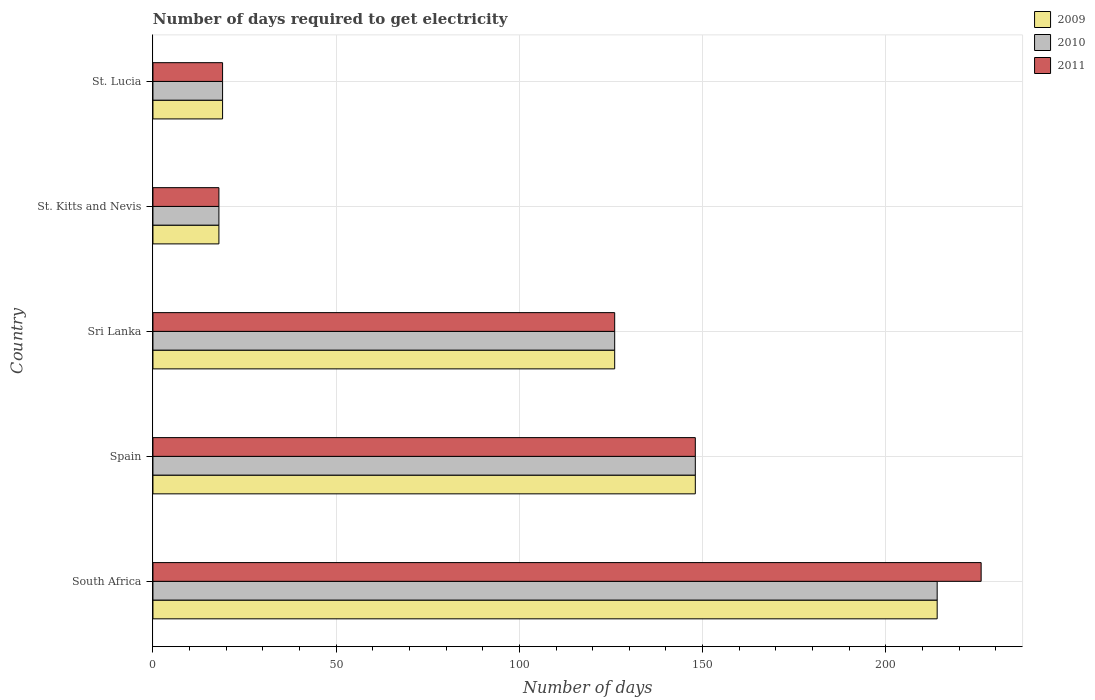How many groups of bars are there?
Provide a succinct answer. 5. Are the number of bars per tick equal to the number of legend labels?
Your response must be concise. Yes. How many bars are there on the 2nd tick from the top?
Your answer should be compact. 3. How many bars are there on the 5th tick from the bottom?
Your answer should be very brief. 3. What is the label of the 3rd group of bars from the top?
Your response must be concise. Sri Lanka. Across all countries, what is the maximum number of days required to get electricity in in 2010?
Your response must be concise. 214. Across all countries, what is the minimum number of days required to get electricity in in 2011?
Your response must be concise. 18. In which country was the number of days required to get electricity in in 2011 maximum?
Keep it short and to the point. South Africa. In which country was the number of days required to get electricity in in 2009 minimum?
Offer a very short reply. St. Kitts and Nevis. What is the total number of days required to get electricity in in 2011 in the graph?
Your answer should be compact. 537. What is the difference between the number of days required to get electricity in in 2010 in Spain and that in Sri Lanka?
Ensure brevity in your answer.  22. What is the difference between the number of days required to get electricity in in 2011 in South Africa and the number of days required to get electricity in in 2010 in St. Lucia?
Provide a short and direct response. 207. What is the average number of days required to get electricity in in 2009 per country?
Keep it short and to the point. 105. What is the difference between the number of days required to get electricity in in 2011 and number of days required to get electricity in in 2010 in Sri Lanka?
Your answer should be compact. 0. In how many countries, is the number of days required to get electricity in in 2011 greater than 200 days?
Offer a terse response. 1. What is the ratio of the number of days required to get electricity in in 2010 in Spain to that in St. Lucia?
Provide a succinct answer. 7.79. Is the difference between the number of days required to get electricity in in 2011 in South Africa and St. Kitts and Nevis greater than the difference between the number of days required to get electricity in in 2010 in South Africa and St. Kitts and Nevis?
Offer a very short reply. Yes. What is the difference between the highest and the second highest number of days required to get electricity in in 2010?
Offer a terse response. 66. What is the difference between the highest and the lowest number of days required to get electricity in in 2009?
Ensure brevity in your answer.  196. Is the sum of the number of days required to get electricity in in 2011 in St. Kitts and Nevis and St. Lucia greater than the maximum number of days required to get electricity in in 2009 across all countries?
Offer a very short reply. No. What does the 1st bar from the bottom in Sri Lanka represents?
Provide a short and direct response. 2009. Is it the case that in every country, the sum of the number of days required to get electricity in in 2011 and number of days required to get electricity in in 2009 is greater than the number of days required to get electricity in in 2010?
Offer a very short reply. Yes. How many bars are there?
Your answer should be very brief. 15. How many countries are there in the graph?
Give a very brief answer. 5. What is the difference between two consecutive major ticks on the X-axis?
Keep it short and to the point. 50. Does the graph contain any zero values?
Provide a short and direct response. No. Does the graph contain grids?
Your answer should be very brief. Yes. Where does the legend appear in the graph?
Keep it short and to the point. Top right. How many legend labels are there?
Provide a succinct answer. 3. What is the title of the graph?
Keep it short and to the point. Number of days required to get electricity. Does "1968" appear as one of the legend labels in the graph?
Offer a very short reply. No. What is the label or title of the X-axis?
Give a very brief answer. Number of days. What is the Number of days in 2009 in South Africa?
Provide a succinct answer. 214. What is the Number of days of 2010 in South Africa?
Give a very brief answer. 214. What is the Number of days of 2011 in South Africa?
Provide a succinct answer. 226. What is the Number of days in 2009 in Spain?
Your response must be concise. 148. What is the Number of days of 2010 in Spain?
Offer a terse response. 148. What is the Number of days of 2011 in Spain?
Give a very brief answer. 148. What is the Number of days of 2009 in Sri Lanka?
Offer a very short reply. 126. What is the Number of days of 2010 in Sri Lanka?
Provide a short and direct response. 126. What is the Number of days in 2011 in Sri Lanka?
Provide a short and direct response. 126. What is the Number of days of 2009 in St. Kitts and Nevis?
Your response must be concise. 18. What is the Number of days in 2010 in St. Lucia?
Offer a terse response. 19. What is the Number of days in 2011 in St. Lucia?
Give a very brief answer. 19. Across all countries, what is the maximum Number of days of 2009?
Give a very brief answer. 214. Across all countries, what is the maximum Number of days of 2010?
Provide a short and direct response. 214. Across all countries, what is the maximum Number of days of 2011?
Your answer should be very brief. 226. Across all countries, what is the minimum Number of days of 2010?
Make the answer very short. 18. What is the total Number of days of 2009 in the graph?
Your answer should be very brief. 525. What is the total Number of days in 2010 in the graph?
Provide a short and direct response. 525. What is the total Number of days in 2011 in the graph?
Your response must be concise. 537. What is the difference between the Number of days in 2009 in South Africa and that in Spain?
Your response must be concise. 66. What is the difference between the Number of days of 2010 in South Africa and that in Spain?
Ensure brevity in your answer.  66. What is the difference between the Number of days of 2011 in South Africa and that in Spain?
Make the answer very short. 78. What is the difference between the Number of days in 2009 in South Africa and that in Sri Lanka?
Provide a succinct answer. 88. What is the difference between the Number of days of 2010 in South Africa and that in Sri Lanka?
Provide a short and direct response. 88. What is the difference between the Number of days in 2009 in South Africa and that in St. Kitts and Nevis?
Give a very brief answer. 196. What is the difference between the Number of days in 2010 in South Africa and that in St. Kitts and Nevis?
Your answer should be very brief. 196. What is the difference between the Number of days of 2011 in South Africa and that in St. Kitts and Nevis?
Your answer should be very brief. 208. What is the difference between the Number of days of 2009 in South Africa and that in St. Lucia?
Provide a short and direct response. 195. What is the difference between the Number of days of 2010 in South Africa and that in St. Lucia?
Your response must be concise. 195. What is the difference between the Number of days in 2011 in South Africa and that in St. Lucia?
Give a very brief answer. 207. What is the difference between the Number of days in 2009 in Spain and that in Sri Lanka?
Offer a very short reply. 22. What is the difference between the Number of days in 2011 in Spain and that in Sri Lanka?
Keep it short and to the point. 22. What is the difference between the Number of days in 2009 in Spain and that in St. Kitts and Nevis?
Give a very brief answer. 130. What is the difference between the Number of days of 2010 in Spain and that in St. Kitts and Nevis?
Your response must be concise. 130. What is the difference between the Number of days in 2011 in Spain and that in St. Kitts and Nevis?
Ensure brevity in your answer.  130. What is the difference between the Number of days in 2009 in Spain and that in St. Lucia?
Give a very brief answer. 129. What is the difference between the Number of days of 2010 in Spain and that in St. Lucia?
Your answer should be very brief. 129. What is the difference between the Number of days in 2011 in Spain and that in St. Lucia?
Keep it short and to the point. 129. What is the difference between the Number of days in 2009 in Sri Lanka and that in St. Kitts and Nevis?
Your response must be concise. 108. What is the difference between the Number of days of 2010 in Sri Lanka and that in St. Kitts and Nevis?
Give a very brief answer. 108. What is the difference between the Number of days in 2011 in Sri Lanka and that in St. Kitts and Nevis?
Offer a very short reply. 108. What is the difference between the Number of days of 2009 in Sri Lanka and that in St. Lucia?
Make the answer very short. 107. What is the difference between the Number of days of 2010 in Sri Lanka and that in St. Lucia?
Your response must be concise. 107. What is the difference between the Number of days of 2011 in Sri Lanka and that in St. Lucia?
Make the answer very short. 107. What is the difference between the Number of days in 2009 in St. Kitts and Nevis and that in St. Lucia?
Provide a succinct answer. -1. What is the difference between the Number of days in 2010 in St. Kitts and Nevis and that in St. Lucia?
Offer a very short reply. -1. What is the difference between the Number of days of 2011 in St. Kitts and Nevis and that in St. Lucia?
Your answer should be compact. -1. What is the difference between the Number of days of 2009 in South Africa and the Number of days of 2011 in Spain?
Your answer should be compact. 66. What is the difference between the Number of days in 2010 in South Africa and the Number of days in 2011 in Spain?
Your answer should be very brief. 66. What is the difference between the Number of days of 2009 in South Africa and the Number of days of 2010 in Sri Lanka?
Provide a succinct answer. 88. What is the difference between the Number of days in 2009 in South Africa and the Number of days in 2011 in Sri Lanka?
Provide a succinct answer. 88. What is the difference between the Number of days in 2009 in South Africa and the Number of days in 2010 in St. Kitts and Nevis?
Offer a very short reply. 196. What is the difference between the Number of days in 2009 in South Africa and the Number of days in 2011 in St. Kitts and Nevis?
Keep it short and to the point. 196. What is the difference between the Number of days in 2010 in South Africa and the Number of days in 2011 in St. Kitts and Nevis?
Provide a succinct answer. 196. What is the difference between the Number of days of 2009 in South Africa and the Number of days of 2010 in St. Lucia?
Ensure brevity in your answer.  195. What is the difference between the Number of days of 2009 in South Africa and the Number of days of 2011 in St. Lucia?
Offer a very short reply. 195. What is the difference between the Number of days in 2010 in South Africa and the Number of days in 2011 in St. Lucia?
Make the answer very short. 195. What is the difference between the Number of days in 2009 in Spain and the Number of days in 2011 in Sri Lanka?
Provide a succinct answer. 22. What is the difference between the Number of days in 2009 in Spain and the Number of days in 2010 in St. Kitts and Nevis?
Offer a terse response. 130. What is the difference between the Number of days in 2009 in Spain and the Number of days in 2011 in St. Kitts and Nevis?
Provide a short and direct response. 130. What is the difference between the Number of days of 2010 in Spain and the Number of days of 2011 in St. Kitts and Nevis?
Ensure brevity in your answer.  130. What is the difference between the Number of days of 2009 in Spain and the Number of days of 2010 in St. Lucia?
Offer a very short reply. 129. What is the difference between the Number of days of 2009 in Spain and the Number of days of 2011 in St. Lucia?
Provide a succinct answer. 129. What is the difference between the Number of days in 2010 in Spain and the Number of days in 2011 in St. Lucia?
Ensure brevity in your answer.  129. What is the difference between the Number of days of 2009 in Sri Lanka and the Number of days of 2010 in St. Kitts and Nevis?
Offer a very short reply. 108. What is the difference between the Number of days of 2009 in Sri Lanka and the Number of days of 2011 in St. Kitts and Nevis?
Your answer should be compact. 108. What is the difference between the Number of days of 2010 in Sri Lanka and the Number of days of 2011 in St. Kitts and Nevis?
Make the answer very short. 108. What is the difference between the Number of days in 2009 in Sri Lanka and the Number of days in 2010 in St. Lucia?
Your response must be concise. 107. What is the difference between the Number of days in 2009 in Sri Lanka and the Number of days in 2011 in St. Lucia?
Ensure brevity in your answer.  107. What is the difference between the Number of days in 2010 in Sri Lanka and the Number of days in 2011 in St. Lucia?
Provide a short and direct response. 107. What is the difference between the Number of days of 2009 in St. Kitts and Nevis and the Number of days of 2010 in St. Lucia?
Keep it short and to the point. -1. What is the difference between the Number of days of 2010 in St. Kitts and Nevis and the Number of days of 2011 in St. Lucia?
Make the answer very short. -1. What is the average Number of days in 2009 per country?
Offer a very short reply. 105. What is the average Number of days of 2010 per country?
Provide a succinct answer. 105. What is the average Number of days in 2011 per country?
Your response must be concise. 107.4. What is the difference between the Number of days of 2009 and Number of days of 2010 in South Africa?
Provide a short and direct response. 0. What is the difference between the Number of days in 2009 and Number of days in 2011 in South Africa?
Your answer should be very brief. -12. What is the difference between the Number of days in 2009 and Number of days in 2010 in Spain?
Give a very brief answer. 0. What is the difference between the Number of days in 2009 and Number of days in 2011 in Spain?
Offer a terse response. 0. What is the difference between the Number of days in 2010 and Number of days in 2011 in Spain?
Provide a succinct answer. 0. What is the difference between the Number of days of 2010 and Number of days of 2011 in Sri Lanka?
Offer a very short reply. 0. What is the difference between the Number of days in 2009 and Number of days in 2011 in St. Kitts and Nevis?
Make the answer very short. 0. What is the difference between the Number of days in 2010 and Number of days in 2011 in St. Kitts and Nevis?
Provide a succinct answer. 0. What is the difference between the Number of days of 2009 and Number of days of 2010 in St. Lucia?
Offer a terse response. 0. What is the difference between the Number of days of 2009 and Number of days of 2011 in St. Lucia?
Your answer should be compact. 0. What is the ratio of the Number of days in 2009 in South Africa to that in Spain?
Make the answer very short. 1.45. What is the ratio of the Number of days in 2010 in South Africa to that in Spain?
Offer a terse response. 1.45. What is the ratio of the Number of days of 2011 in South Africa to that in Spain?
Keep it short and to the point. 1.53. What is the ratio of the Number of days of 2009 in South Africa to that in Sri Lanka?
Provide a short and direct response. 1.7. What is the ratio of the Number of days of 2010 in South Africa to that in Sri Lanka?
Provide a succinct answer. 1.7. What is the ratio of the Number of days of 2011 in South Africa to that in Sri Lanka?
Provide a short and direct response. 1.79. What is the ratio of the Number of days in 2009 in South Africa to that in St. Kitts and Nevis?
Give a very brief answer. 11.89. What is the ratio of the Number of days in 2010 in South Africa to that in St. Kitts and Nevis?
Provide a succinct answer. 11.89. What is the ratio of the Number of days in 2011 in South Africa to that in St. Kitts and Nevis?
Make the answer very short. 12.56. What is the ratio of the Number of days of 2009 in South Africa to that in St. Lucia?
Keep it short and to the point. 11.26. What is the ratio of the Number of days in 2010 in South Africa to that in St. Lucia?
Your response must be concise. 11.26. What is the ratio of the Number of days of 2011 in South Africa to that in St. Lucia?
Your response must be concise. 11.89. What is the ratio of the Number of days of 2009 in Spain to that in Sri Lanka?
Offer a very short reply. 1.17. What is the ratio of the Number of days in 2010 in Spain to that in Sri Lanka?
Make the answer very short. 1.17. What is the ratio of the Number of days of 2011 in Spain to that in Sri Lanka?
Keep it short and to the point. 1.17. What is the ratio of the Number of days of 2009 in Spain to that in St. Kitts and Nevis?
Offer a terse response. 8.22. What is the ratio of the Number of days in 2010 in Spain to that in St. Kitts and Nevis?
Provide a short and direct response. 8.22. What is the ratio of the Number of days of 2011 in Spain to that in St. Kitts and Nevis?
Ensure brevity in your answer.  8.22. What is the ratio of the Number of days of 2009 in Spain to that in St. Lucia?
Keep it short and to the point. 7.79. What is the ratio of the Number of days of 2010 in Spain to that in St. Lucia?
Provide a succinct answer. 7.79. What is the ratio of the Number of days in 2011 in Spain to that in St. Lucia?
Offer a terse response. 7.79. What is the ratio of the Number of days in 2009 in Sri Lanka to that in St. Kitts and Nevis?
Your answer should be very brief. 7. What is the ratio of the Number of days in 2009 in Sri Lanka to that in St. Lucia?
Ensure brevity in your answer.  6.63. What is the ratio of the Number of days in 2010 in Sri Lanka to that in St. Lucia?
Provide a short and direct response. 6.63. What is the ratio of the Number of days in 2011 in Sri Lanka to that in St. Lucia?
Give a very brief answer. 6.63. What is the ratio of the Number of days in 2009 in St. Kitts and Nevis to that in St. Lucia?
Your response must be concise. 0.95. What is the ratio of the Number of days in 2011 in St. Kitts and Nevis to that in St. Lucia?
Offer a terse response. 0.95. What is the difference between the highest and the second highest Number of days of 2009?
Your answer should be compact. 66. What is the difference between the highest and the second highest Number of days in 2010?
Ensure brevity in your answer.  66. What is the difference between the highest and the lowest Number of days in 2009?
Offer a very short reply. 196. What is the difference between the highest and the lowest Number of days in 2010?
Keep it short and to the point. 196. What is the difference between the highest and the lowest Number of days in 2011?
Make the answer very short. 208. 